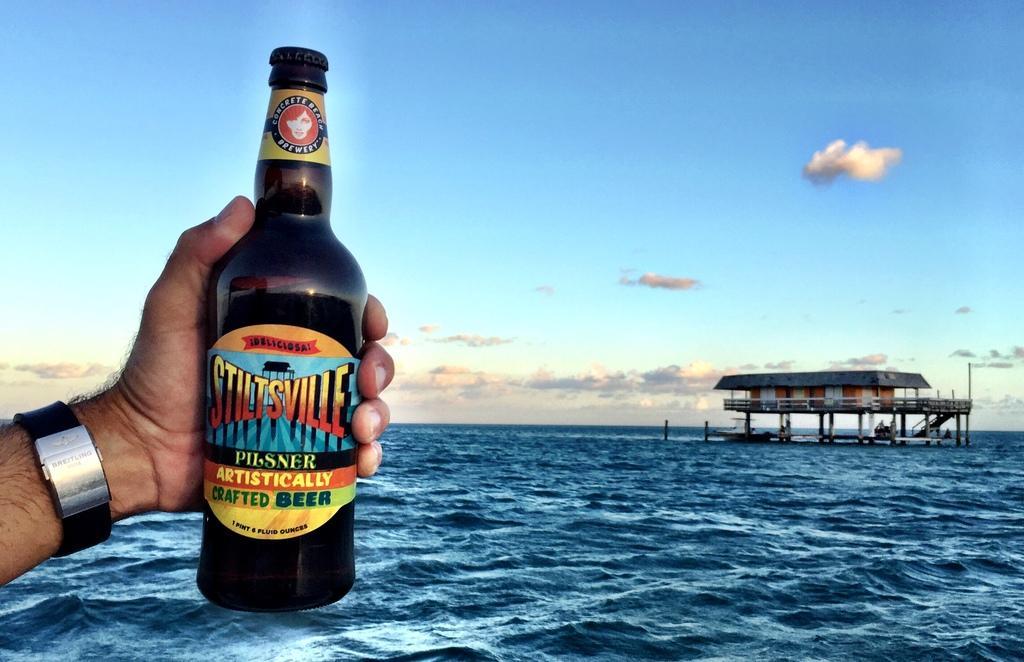How would you summarize this image in a sentence or two? In this picture we can see the persons, who is wearing watch and holding wine bottle. On the right there is a house which is constructed above the water. In the background we can see ocean. At the top we can see sky and clouds. 